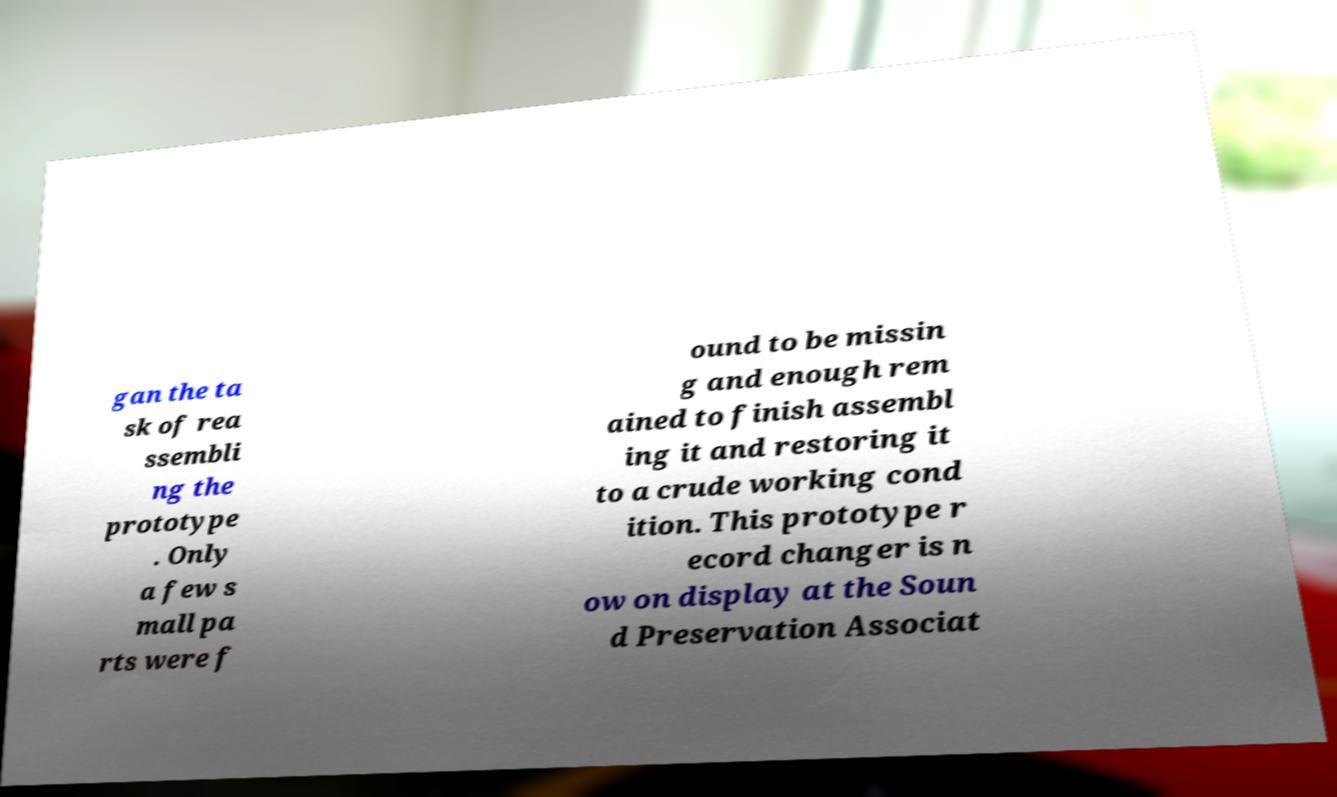Please read and relay the text visible in this image. What does it say? gan the ta sk of rea ssembli ng the prototype . Only a few s mall pa rts were f ound to be missin g and enough rem ained to finish assembl ing it and restoring it to a crude working cond ition. This prototype r ecord changer is n ow on display at the Soun d Preservation Associat 